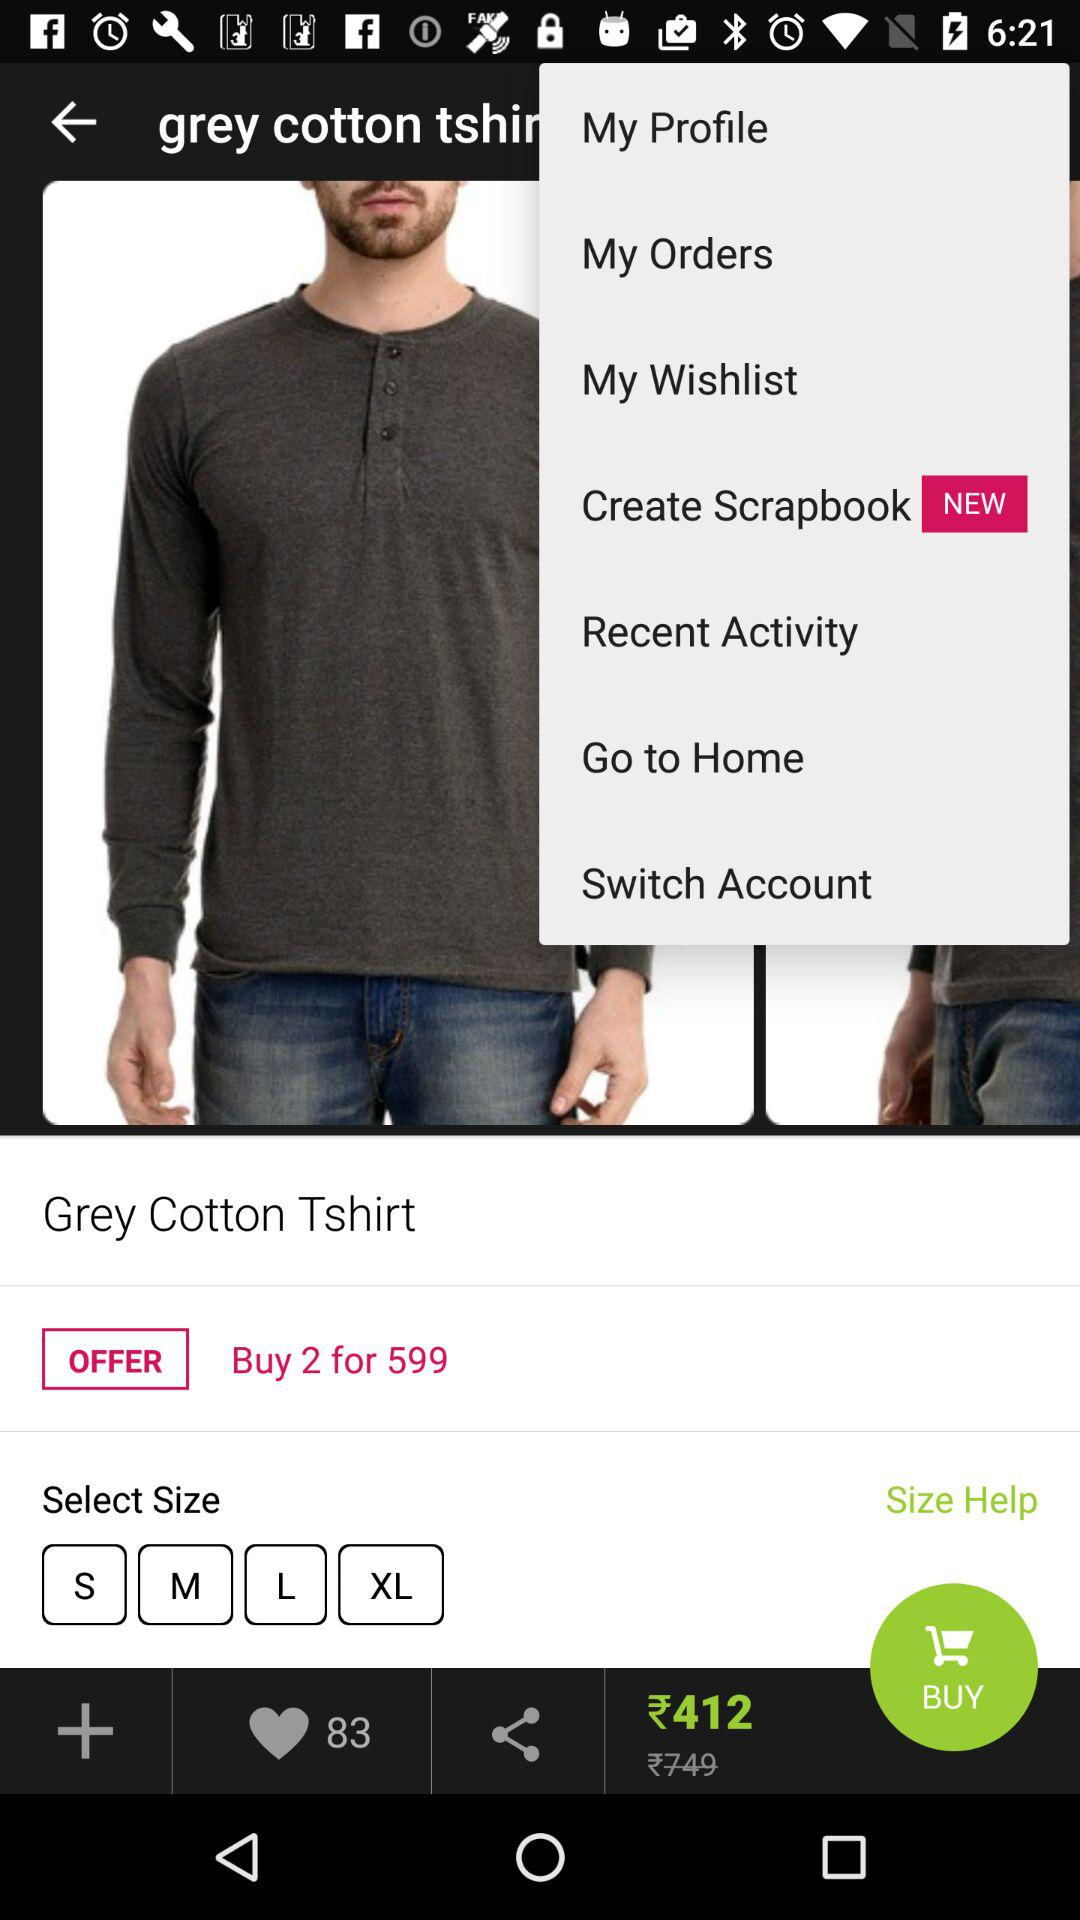How much of an offer price do we get if we buy 2 shirts? If you buy 2 shirts, you will get an offer price of ₹599. 